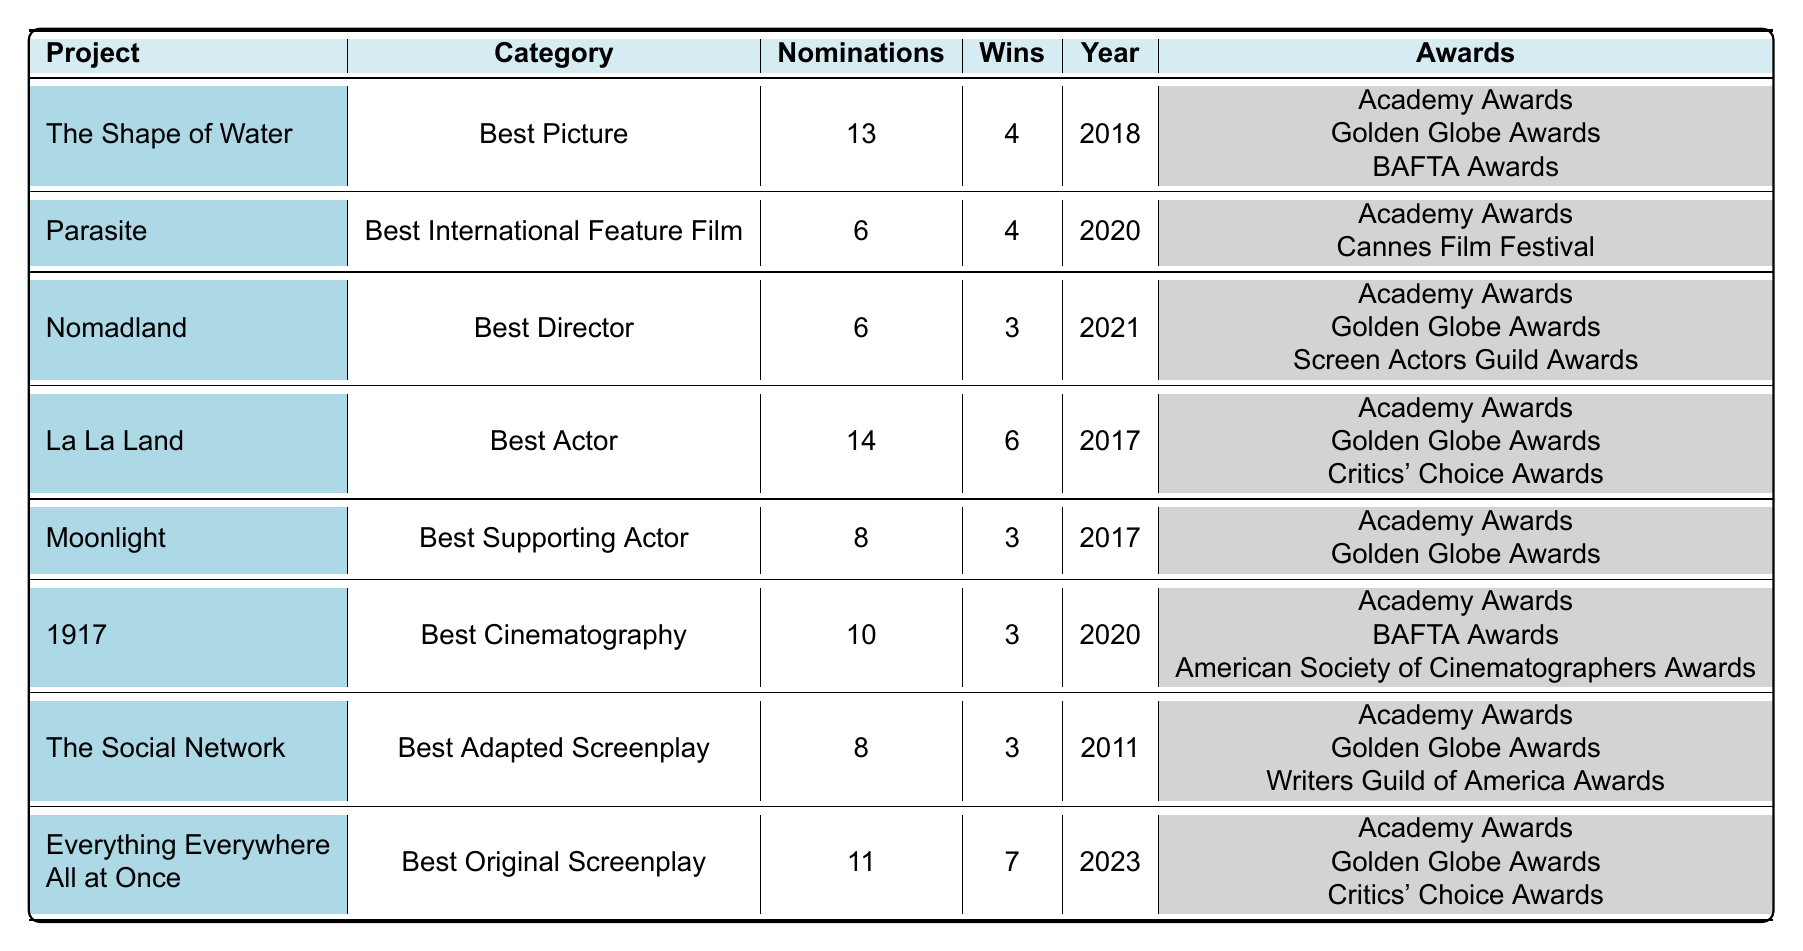What project won the most awards? In the table, "Everything Everywhere All at Once" has won 7 awards, which is the highest number among all listed projects.
Answer: Everything Everywhere All at Once How many nominations did La La Land receive? By looking at the table, "La La Land" has received 14 nominations, which is stated in its respective row.
Answer: 14 Which project was nominated in the year 2020? The table lists "Parasite" and "1917" as the projects that were nominated in the year 2020.
Answer: Parasite, 1917 What is the total number of wins for projects in the Best Actor category? The only project in the Best Actor category is "La La Land," which won 6 awards. Thus, the total number of wins is simply 6.
Answer: 6 Which project has the least number of wins? By checking the table, both "Moonlight," "1917," "The Social Network," and "Nomadland" all have 3 wins each, making them the projects with the least wins.
Answer: Moonlight, 1917, The Social Network, Nomadland Did "The Shape of Water" ever win an award at the Academy Awards? Yes, "The Shape of Water" won 4 awards and is listed as a nominee for the Academy Awards in the table.
Answer: Yes What is the average number of nominations across all listed projects? To find the average, we sum the nominations (13 + 6 + 6 + 14 + 8 + 10 + 8 + 11 = 76) and divide by the number of projects (8), giving us an average of 9.5.
Answer: 9.5 Which category had the most nominations? The "Best Actor" category for "La La Land" has the most nominations, totaling 14, which is higher than any other category.
Answer: Best Actor How many awards did "Nomadland" win compared to its nominations? "Nomadland" has 3 wins out of 6 nominations; thus, it has a win ratio of 3/6 or 50%.
Answer: 3 wins What is the difference between total nominations and total wins for "Everything Everywhere All at Once"? "Everything Everywhere All at Once" received 11 nominations and won 7 awards. The difference is 11 - 7 = 4.
Answer: 4 